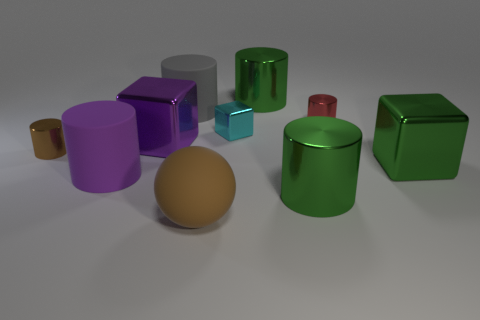Which object stands out the most based on its size and color? The object that stands out prominently based on its size and color is the brown sphere. Its size is substantial relative to the other items, and its earthy brown tone contrasts with the more vibrant shades surrounding it. 